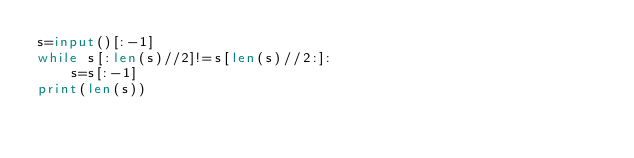<code> <loc_0><loc_0><loc_500><loc_500><_Python_>s=input()[:-1]
while s[:len(s)//2]!=s[len(s)//2:]:
    s=s[:-1]
print(len(s))

        
    </code> 